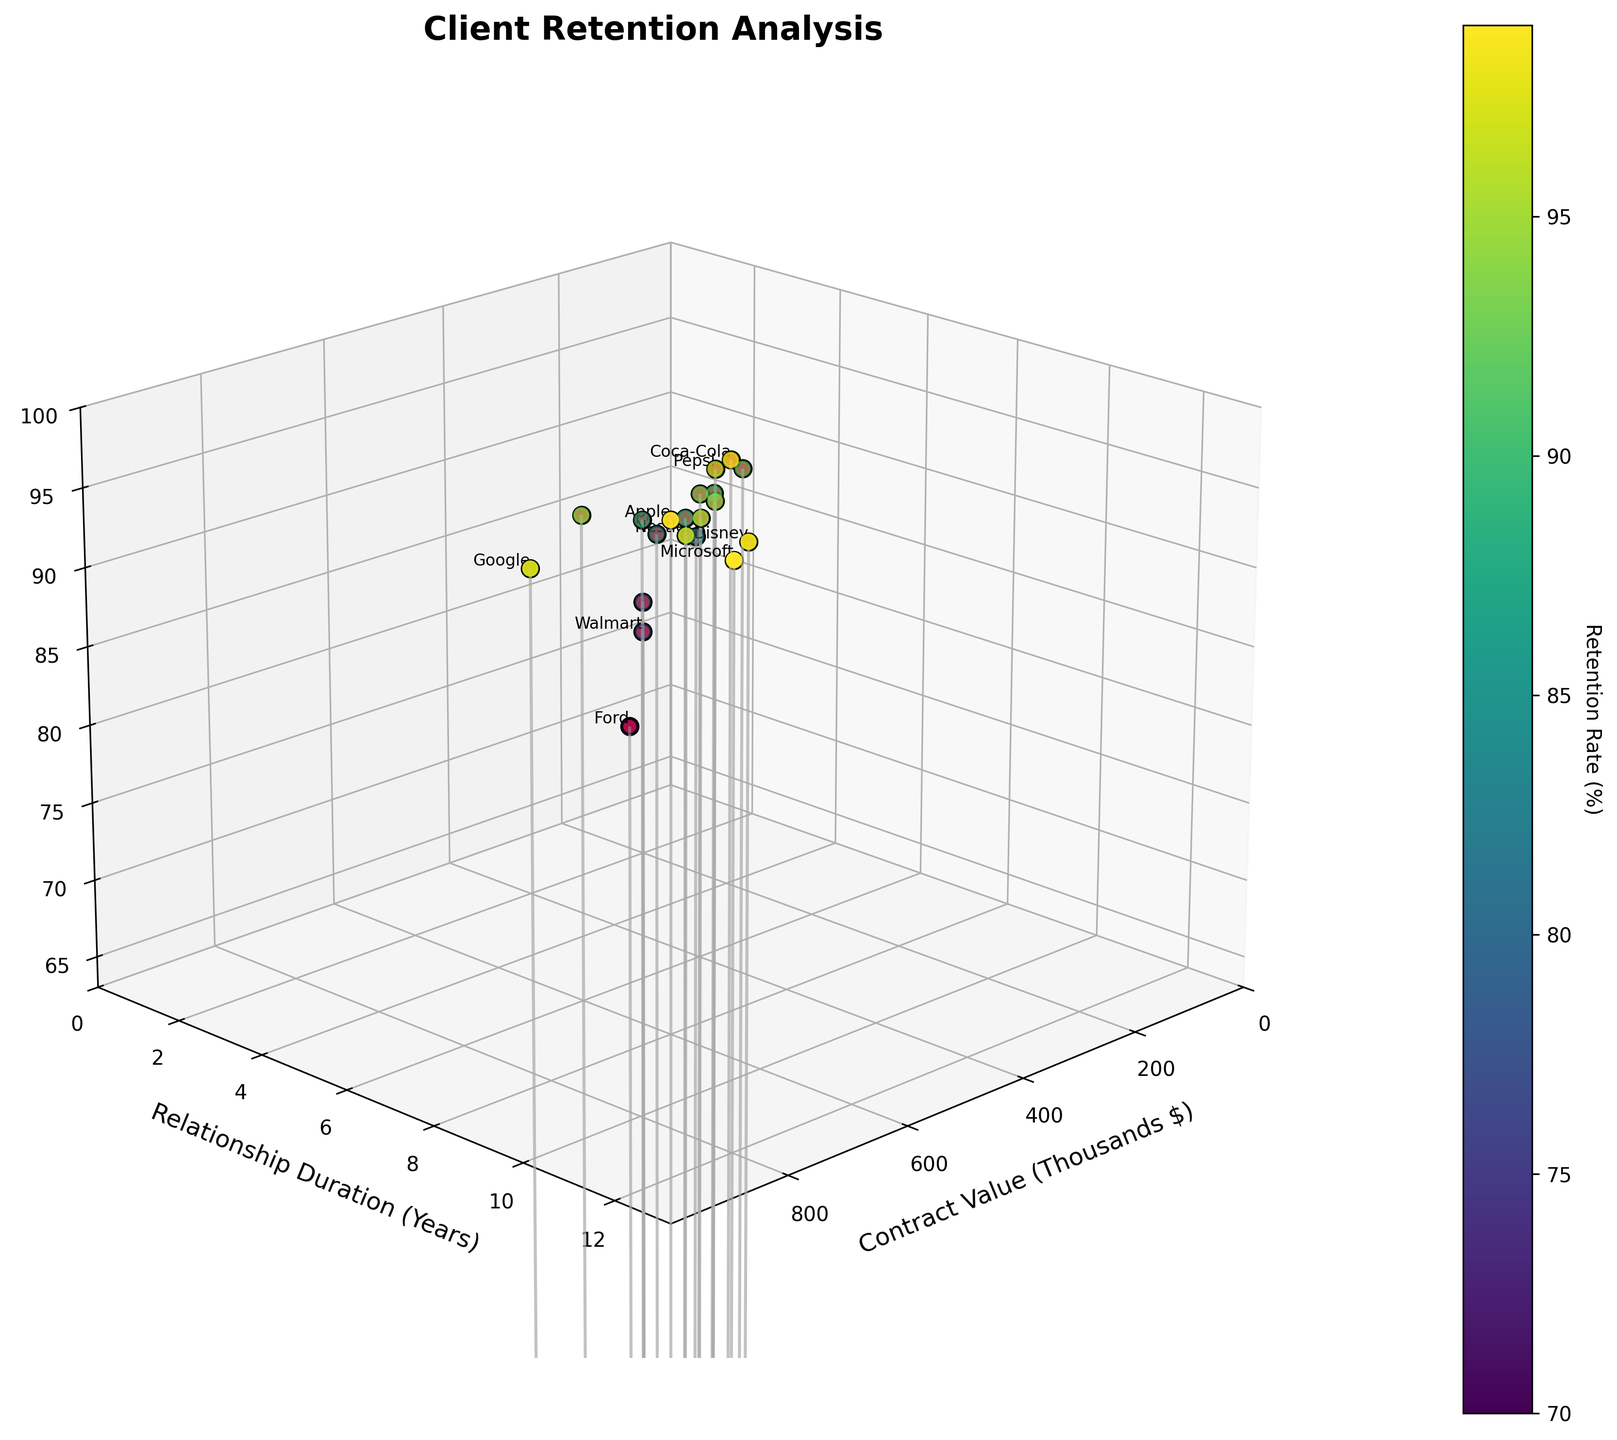what is the title of the plot? The title of the plot is shown at the top of the figure. It reads, 'Client Retention Analysis.'
Answer: Client Retention Analysis which client has the highest contract value? The client with the highest contract value is represented by the point farthest along the x-axis. The text label on this point is 'Google' with $900,000.
Answer: Google what's the range of retention rates displayed in the plot? The retention rates can be inferred from the z-axis, ranging from the lowest visible value to the highest. The z-axis ranges from around 70% to 99%.
Answer: 70% to 99% how does the retention rate of Nike compare to that of Adidas? Nike has a retention rate represented by a z-value of 92, and Adidas by a z-value of 85. Comparing these values indicates that Nike's retention rate is higher than that of Adidas.
Answer: Nike has a higher retention rate what correlation can be observed between contract value and retention rates? Observing the stem plot, a general trend shows that clients with higher contract values tend to have higher retention rates.
Answer: Higher contract values generally lead to higher retention rates which client has the lowest retention rate and what is it? The point with the lowest z value corresponds to Ford. This point has the label "70" on the z-axis.
Answer: Ford at 70% how many clients have a retention rate of 99%? Observing the z-axis and corresponding clients, both Apple and Microsoft have data points that reach 99%.
Answer: 2 clients what is the average contract value for clients lasting 8 years or more? Identify the clients with a relationship duration of 8 years or more: Coca-Cola, P&G, Nestle, Google, and Disney. Add their contract values ($500,000, $550,000, $650,000, $900,000, $700,000) and divide by the number of clients (5). The average is ($500,000 + $550,000 + $650,000 + $900,000 + $700,000) / 5 = $660,000.
Answer: $660,000 between Amazon and Walmart, who has a better retention rate? Compare the z-values of Amazon and Walmart. Amazon's retention rate is 89%, while Walmart's is 78%.
Answer: Amazon 